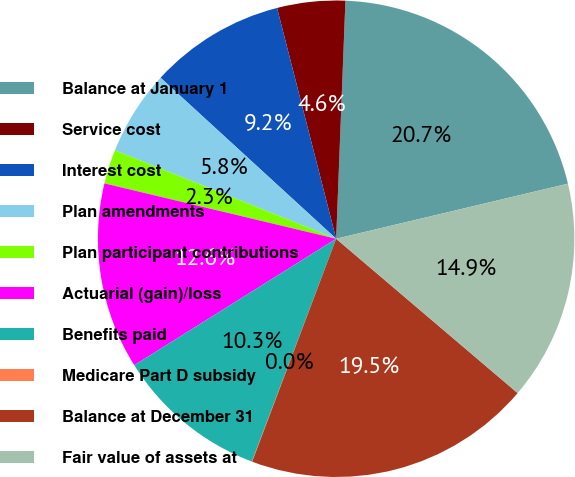Convert chart to OTSL. <chart><loc_0><loc_0><loc_500><loc_500><pie_chart><fcel>Balance at January 1<fcel>Service cost<fcel>Interest cost<fcel>Plan amendments<fcel>Plan participant contributions<fcel>Actuarial (gain)/loss<fcel>Benefits paid<fcel>Medicare Part D subsidy<fcel>Balance at December 31<fcel>Fair value of assets at<nl><fcel>20.67%<fcel>4.61%<fcel>9.2%<fcel>5.76%<fcel>2.32%<fcel>12.64%<fcel>10.34%<fcel>0.02%<fcel>19.52%<fcel>14.93%<nl></chart> 